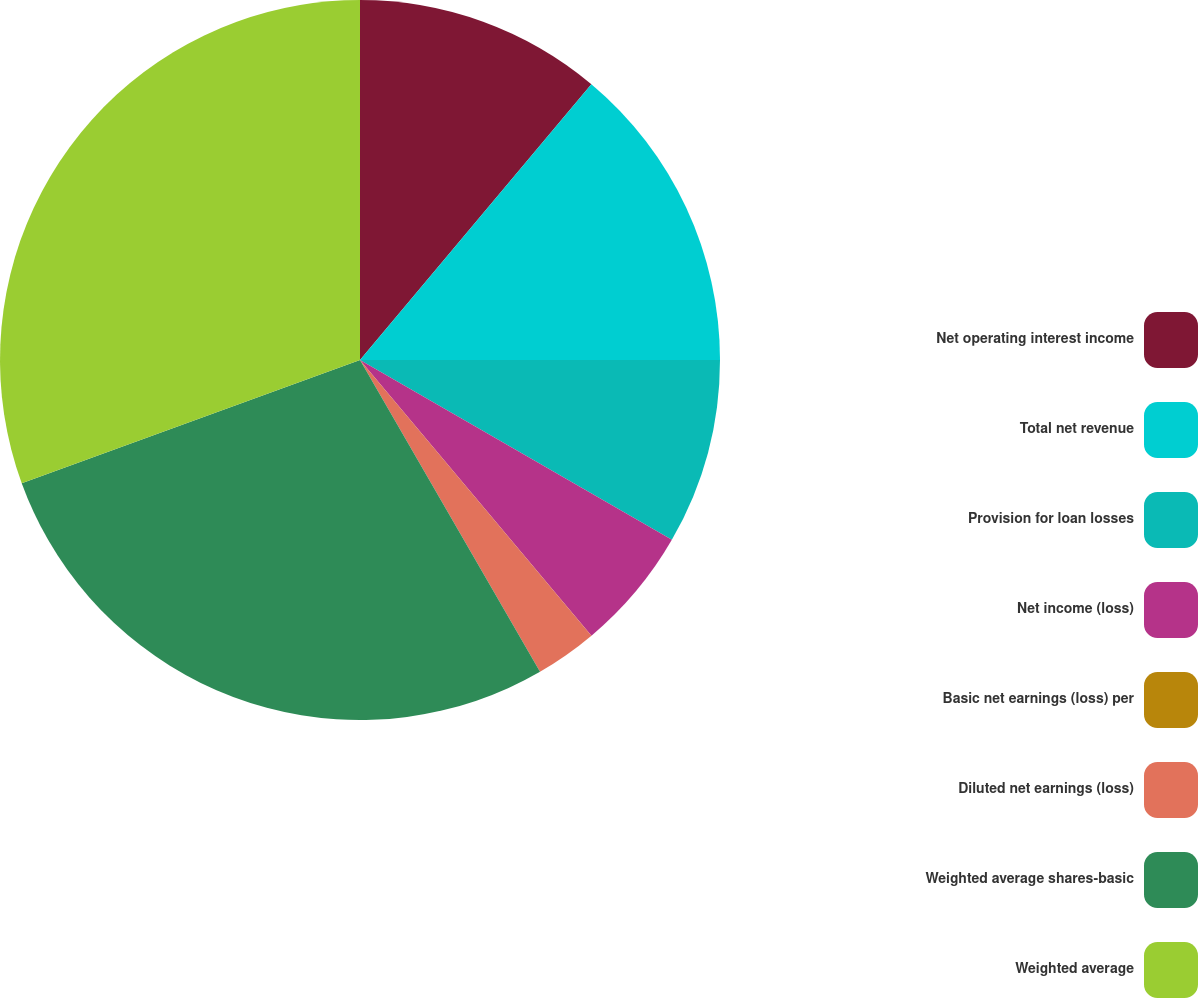<chart> <loc_0><loc_0><loc_500><loc_500><pie_chart><fcel>Net operating interest income<fcel>Total net revenue<fcel>Provision for loan losses<fcel>Net income (loss)<fcel>Basic net earnings (loss) per<fcel>Diluted net earnings (loss)<fcel>Weighted average shares-basic<fcel>Weighted average<nl><fcel>11.11%<fcel>13.89%<fcel>8.33%<fcel>5.56%<fcel>0.0%<fcel>2.78%<fcel>27.78%<fcel>30.56%<nl></chart> 